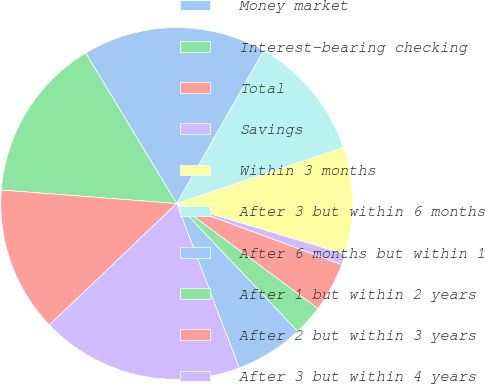Convert chart. <chart><loc_0><loc_0><loc_500><loc_500><pie_chart><fcel>Money market<fcel>Interest-bearing checking<fcel>Total<fcel>Savings<fcel>Within 3 months<fcel>After 3 but within 6 months<fcel>After 6 months but within 1<fcel>After 1 but within 2 years<fcel>After 2 but within 3 years<fcel>After 3 but within 4 years<nl><fcel>6.29%<fcel>2.76%<fcel>4.53%<fcel>1.0%<fcel>9.82%<fcel>11.59%<fcel>16.88%<fcel>15.12%<fcel>13.35%<fcel>18.65%<nl></chart> 